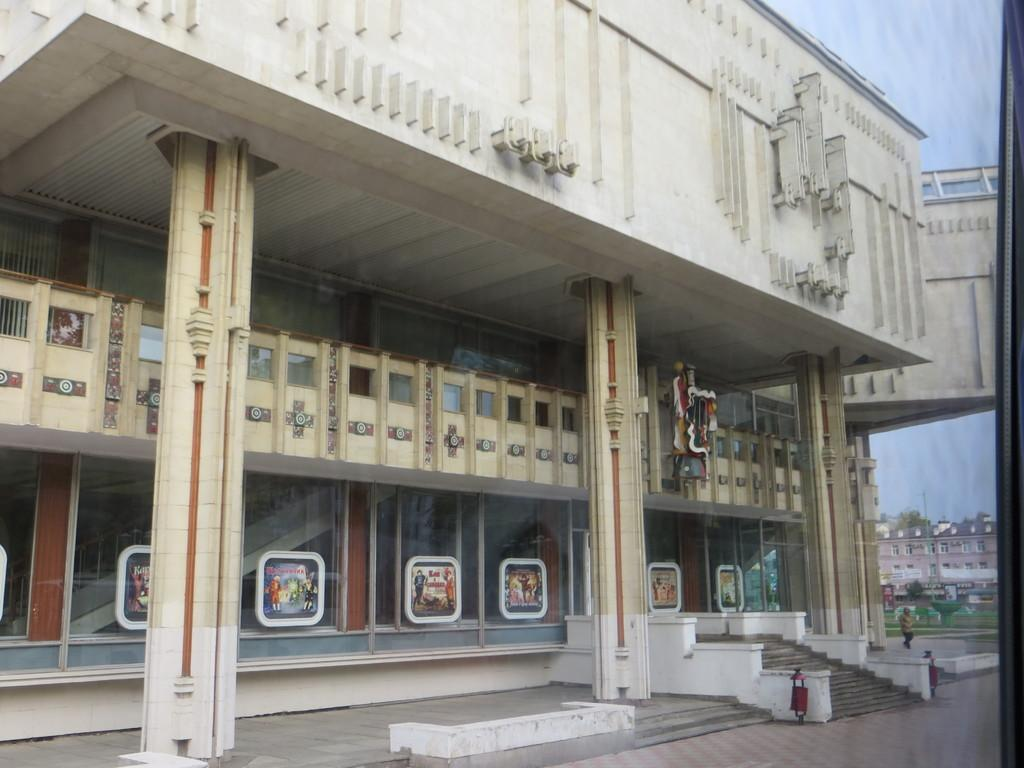What type of building is in the image? There is a building with glass windows in the windows in the image. What is happening in the foreground of the image? There is a person walking on a path in the image. Where is the person located in relation to the building? The person is on the right side of the building. What can be seen in the background of the image? There are other buildings and the sky visible in the background of the image. What type of music is the band playing in the background of the image? There is no band present in the image, so it is not possible to determine what type of music they might be playing. 